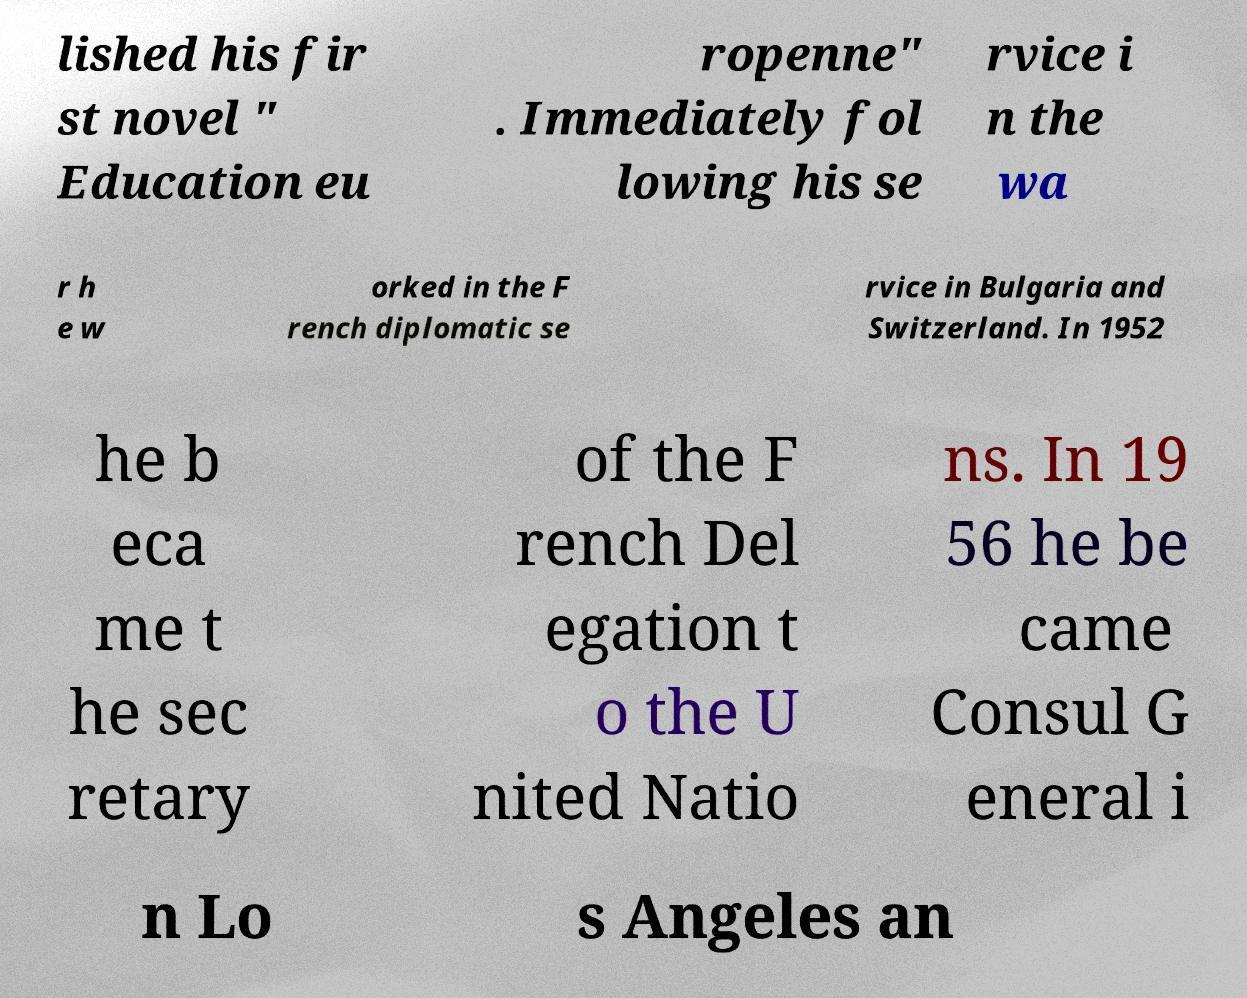Could you assist in decoding the text presented in this image and type it out clearly? lished his fir st novel " Education eu ropenne" . Immediately fol lowing his se rvice i n the wa r h e w orked in the F rench diplomatic se rvice in Bulgaria and Switzerland. In 1952 he b eca me t he sec retary of the F rench Del egation t o the U nited Natio ns. In 19 56 he be came Consul G eneral i n Lo s Angeles an 